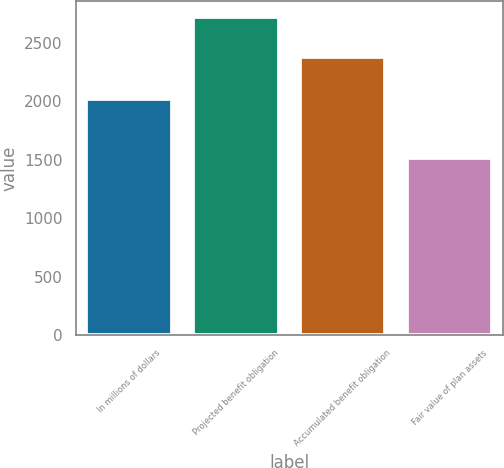Convert chart to OTSL. <chart><loc_0><loc_0><loc_500><loc_500><bar_chart><fcel>In millions of dollars<fcel>Projected benefit obligation<fcel>Accumulated benefit obligation<fcel>Fair value of plan assets<nl><fcel>2017<fcel>2721<fcel>2381<fcel>1516<nl></chart> 